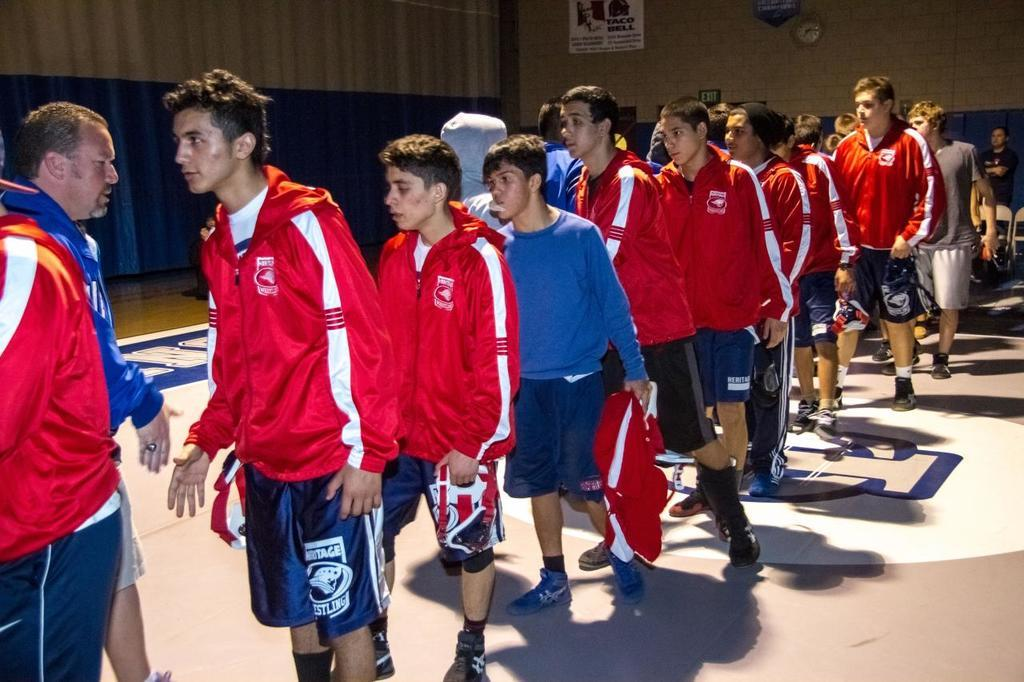How many people are in the image? There is a group of people in the image, but the exact number cannot be determined from the provided facts. What are the people in the image doing? The people are on the ground, but their specific activity is not mentioned in the facts. What can be seen in the background of the image? There is a wall, a clock, and some objects in the background of the image. Can you see a sink in the image? There is no mention of a sink in the provided facts. 